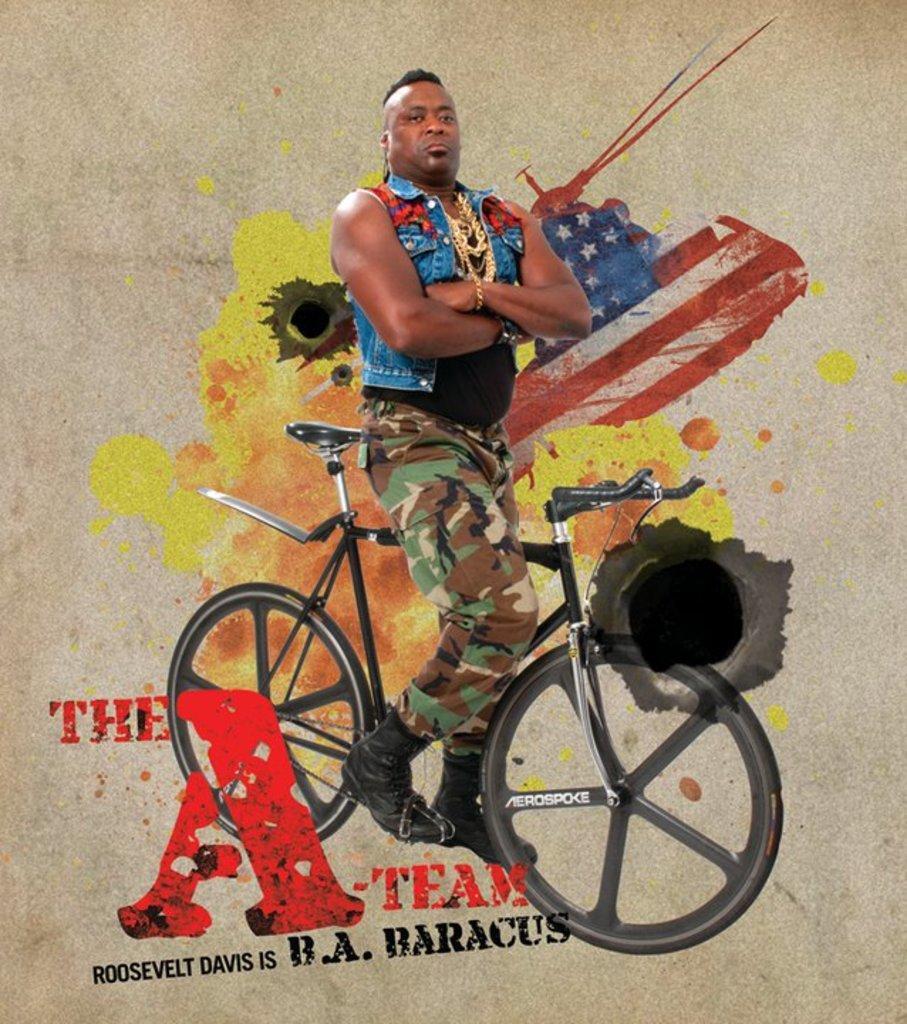Can you describe this image briefly? In this Image I see a man and i see a cycle over here. I see that this is a painting. 